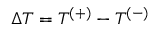<formula> <loc_0><loc_0><loc_500><loc_500>\Delta T = T ^ { ( + ) } - T ^ { ( - ) }</formula> 